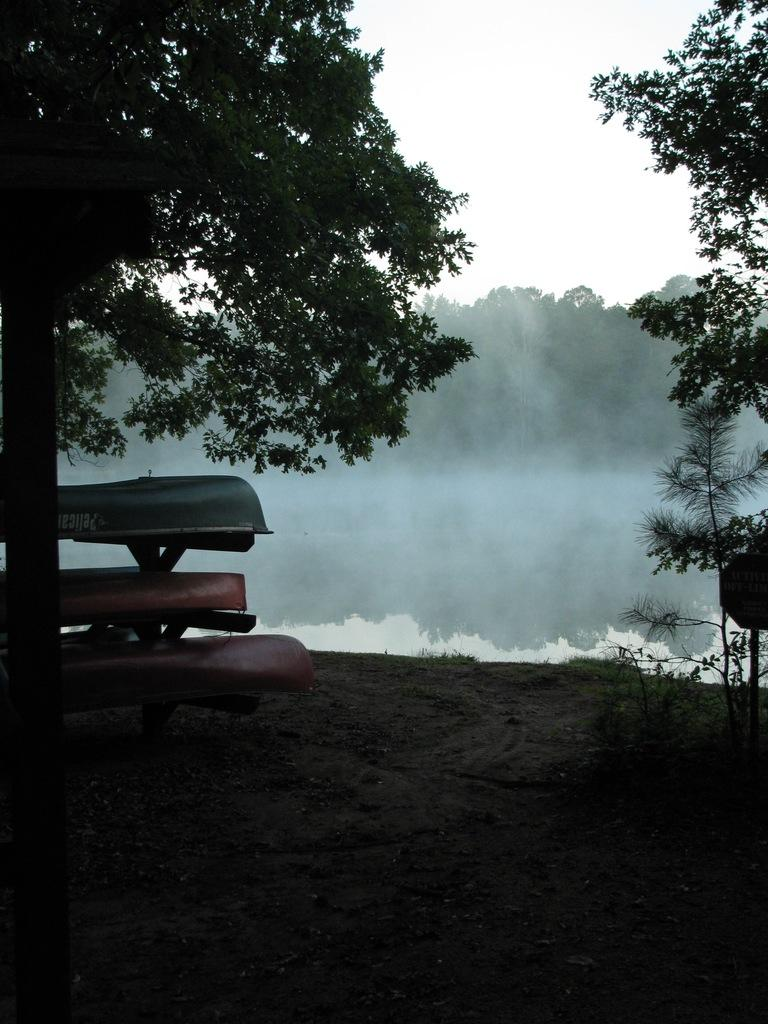What type of natural elements can be seen in the image? There are trees and water visible in the image. What is located on the ground in the image? There is an object on the ground in the image. What part of the natural environment is visible in the image? The sky is visible in the image. What type of legal advice is the daughter seeking in the image? There is no lawyer, daughter, or any indication of seeking legal advice in the image. 